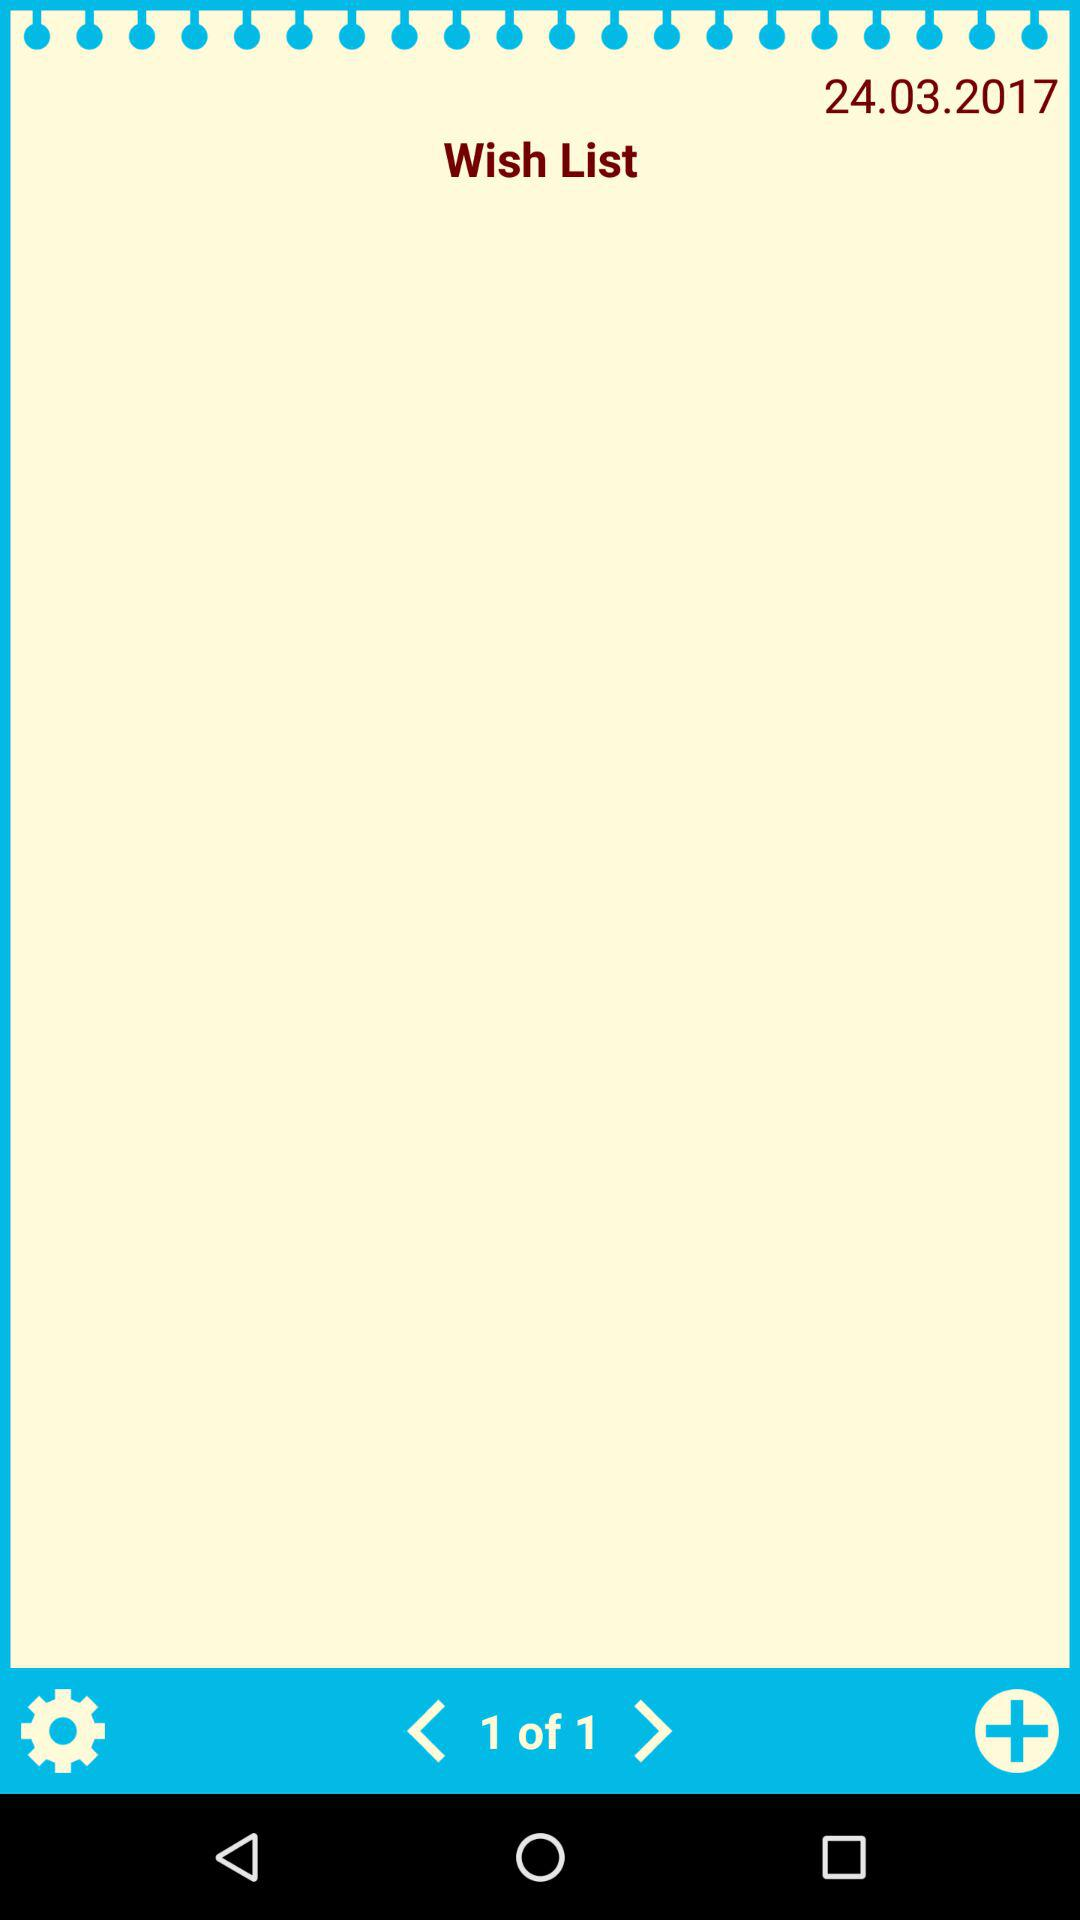How many arrows are on the page?
Answer the question using a single word or phrase. 2 